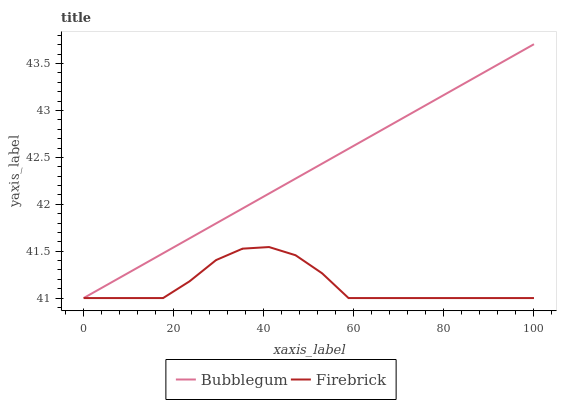Does Firebrick have the minimum area under the curve?
Answer yes or no. Yes. Does Bubblegum have the maximum area under the curve?
Answer yes or no. Yes. Does Bubblegum have the minimum area under the curve?
Answer yes or no. No. Is Bubblegum the smoothest?
Answer yes or no. Yes. Is Firebrick the roughest?
Answer yes or no. Yes. Is Bubblegum the roughest?
Answer yes or no. No. Does Firebrick have the lowest value?
Answer yes or no. Yes. Does Bubblegum have the highest value?
Answer yes or no. Yes. Does Firebrick intersect Bubblegum?
Answer yes or no. Yes. Is Firebrick less than Bubblegum?
Answer yes or no. No. Is Firebrick greater than Bubblegum?
Answer yes or no. No. 